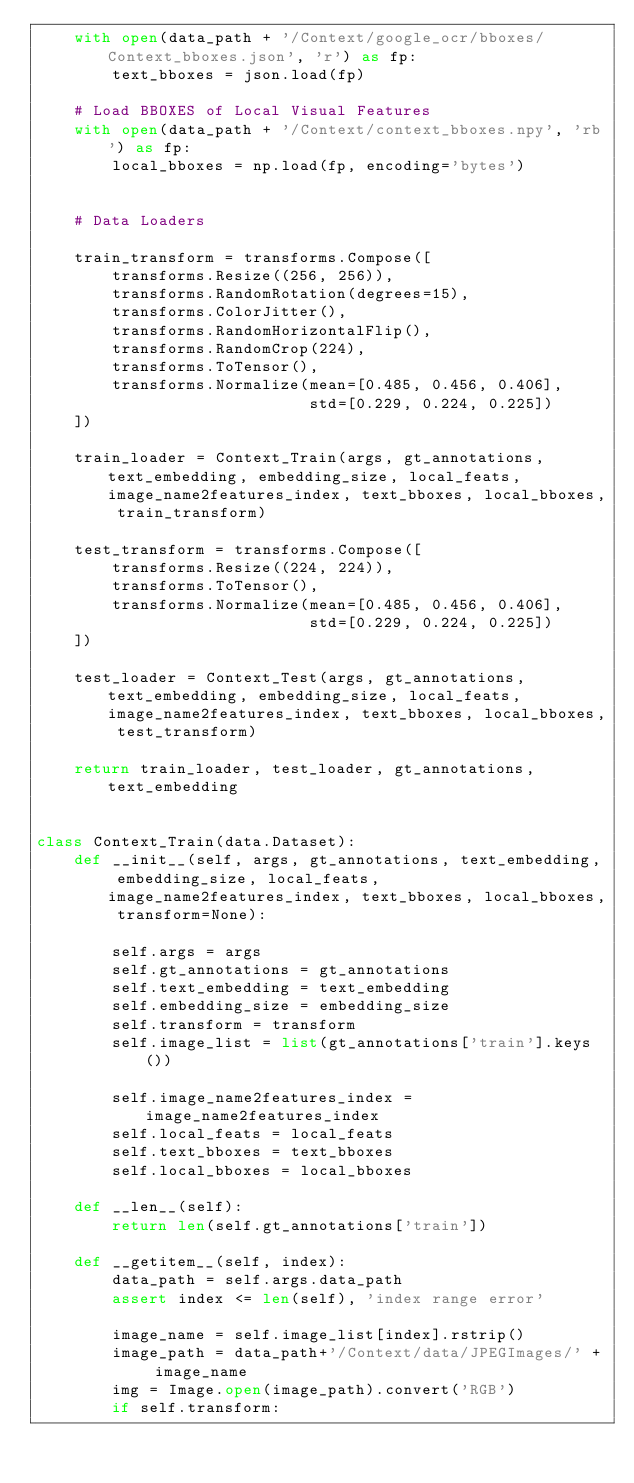Convert code to text. <code><loc_0><loc_0><loc_500><loc_500><_Python_>    with open(data_path + '/Context/google_ocr/bboxes/Context_bboxes.json', 'r') as fp:
        text_bboxes = json.load(fp)

    # Load BBOXES of Local Visual Features
    with open(data_path + '/Context/context_bboxes.npy', 'rb') as fp:
        local_bboxes = np.load(fp, encoding='bytes')


    # Data Loaders

    train_transform = transforms.Compose([
        transforms.Resize((256, 256)),
        transforms.RandomRotation(degrees=15),
        transforms.ColorJitter(),
        transforms.RandomHorizontalFlip(),
        transforms.RandomCrop(224),
        transforms.ToTensor(),
        transforms.Normalize(mean=[0.485, 0.456, 0.406],
                             std=[0.229, 0.224, 0.225])
    ])

    train_loader = Context_Train(args, gt_annotations, text_embedding, embedding_size, local_feats, image_name2features_index, text_bboxes, local_bboxes, train_transform)

    test_transform = transforms.Compose([
        transforms.Resize((224, 224)),
        transforms.ToTensor(),
        transforms.Normalize(mean=[0.485, 0.456, 0.406],
                             std=[0.229, 0.224, 0.225])
    ])

    test_loader = Context_Test(args, gt_annotations, text_embedding, embedding_size, local_feats, image_name2features_index, text_bboxes, local_bboxes, test_transform)

    return train_loader, test_loader, gt_annotations, text_embedding


class Context_Train(data.Dataset):
    def __init__(self, args, gt_annotations, text_embedding, embedding_size, local_feats, image_name2features_index, text_bboxes, local_bboxes, transform=None):

        self.args = args
        self.gt_annotations = gt_annotations
        self.text_embedding = text_embedding
        self.embedding_size = embedding_size
        self.transform = transform
        self.image_list = list(gt_annotations['train'].keys())

        self.image_name2features_index = image_name2features_index
        self.local_feats = local_feats
        self.text_bboxes = text_bboxes
        self.local_bboxes = local_bboxes

    def __len__(self):
        return len(self.gt_annotations['train'])

    def __getitem__(self, index):
        data_path = self.args.data_path
        assert index <= len(self), 'index range error'

        image_name = self.image_list[index].rstrip()
        image_path = data_path+'/Context/data/JPEGImages/' + image_name
        img = Image.open(image_path).convert('RGB')
        if self.transform:</code> 